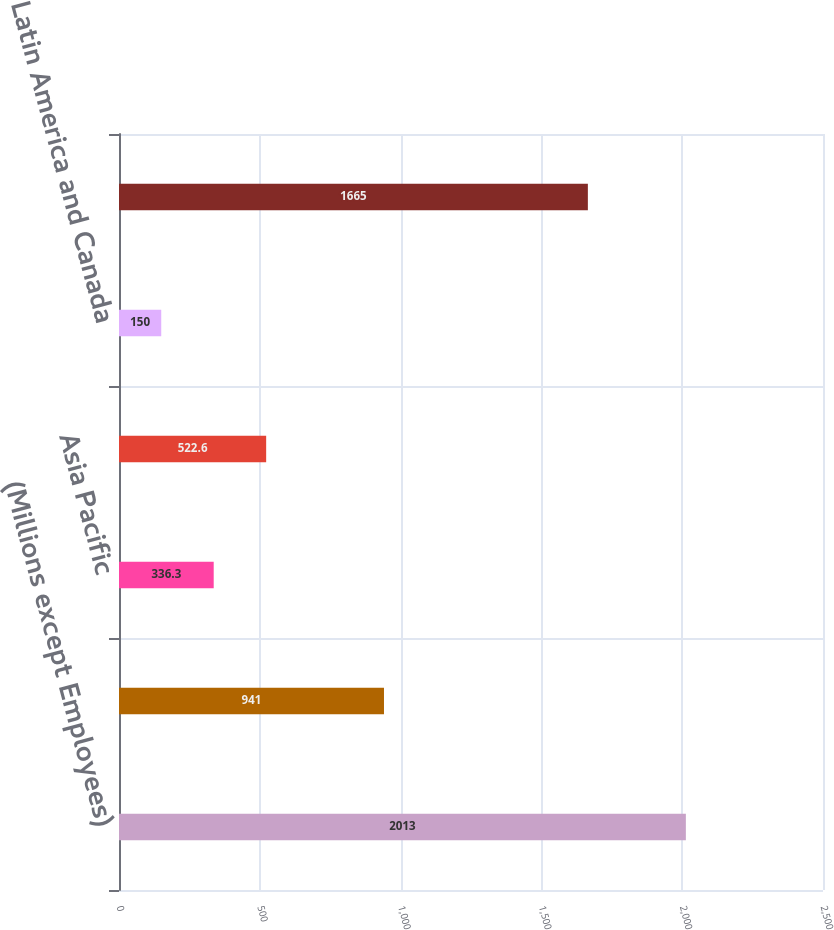Convert chart to OTSL. <chart><loc_0><loc_0><loc_500><loc_500><bar_chart><fcel>(Millions except Employees)<fcel>United States<fcel>Asia Pacific<fcel>Europe Middle East and Africa<fcel>Latin America and Canada<fcel>Total Company<nl><fcel>2013<fcel>941<fcel>336.3<fcel>522.6<fcel>150<fcel>1665<nl></chart> 